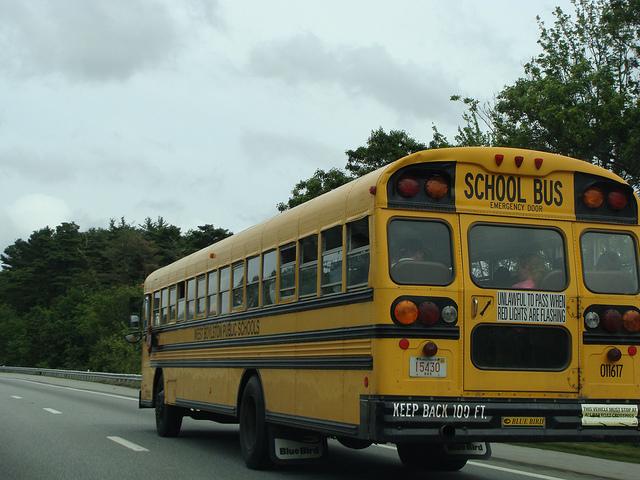How many school buses on the street?
Concise answer only. 1. What number is on the left side of the bus?
Give a very brief answer. 15430. How far do you have to keep back from the bus?
Short answer required. 100 ft. How many windows are down?
Be succinct. 5. Are there people on the bus?
Give a very brief answer. Yes. Is the bus parked?
Concise answer only. No. Does this bus have a typical paint job?
Quick response, please. Yes. Does this bus have students on it?
Answer briefly. Yes. What is the bus number?
Concise answer only. 011617. 